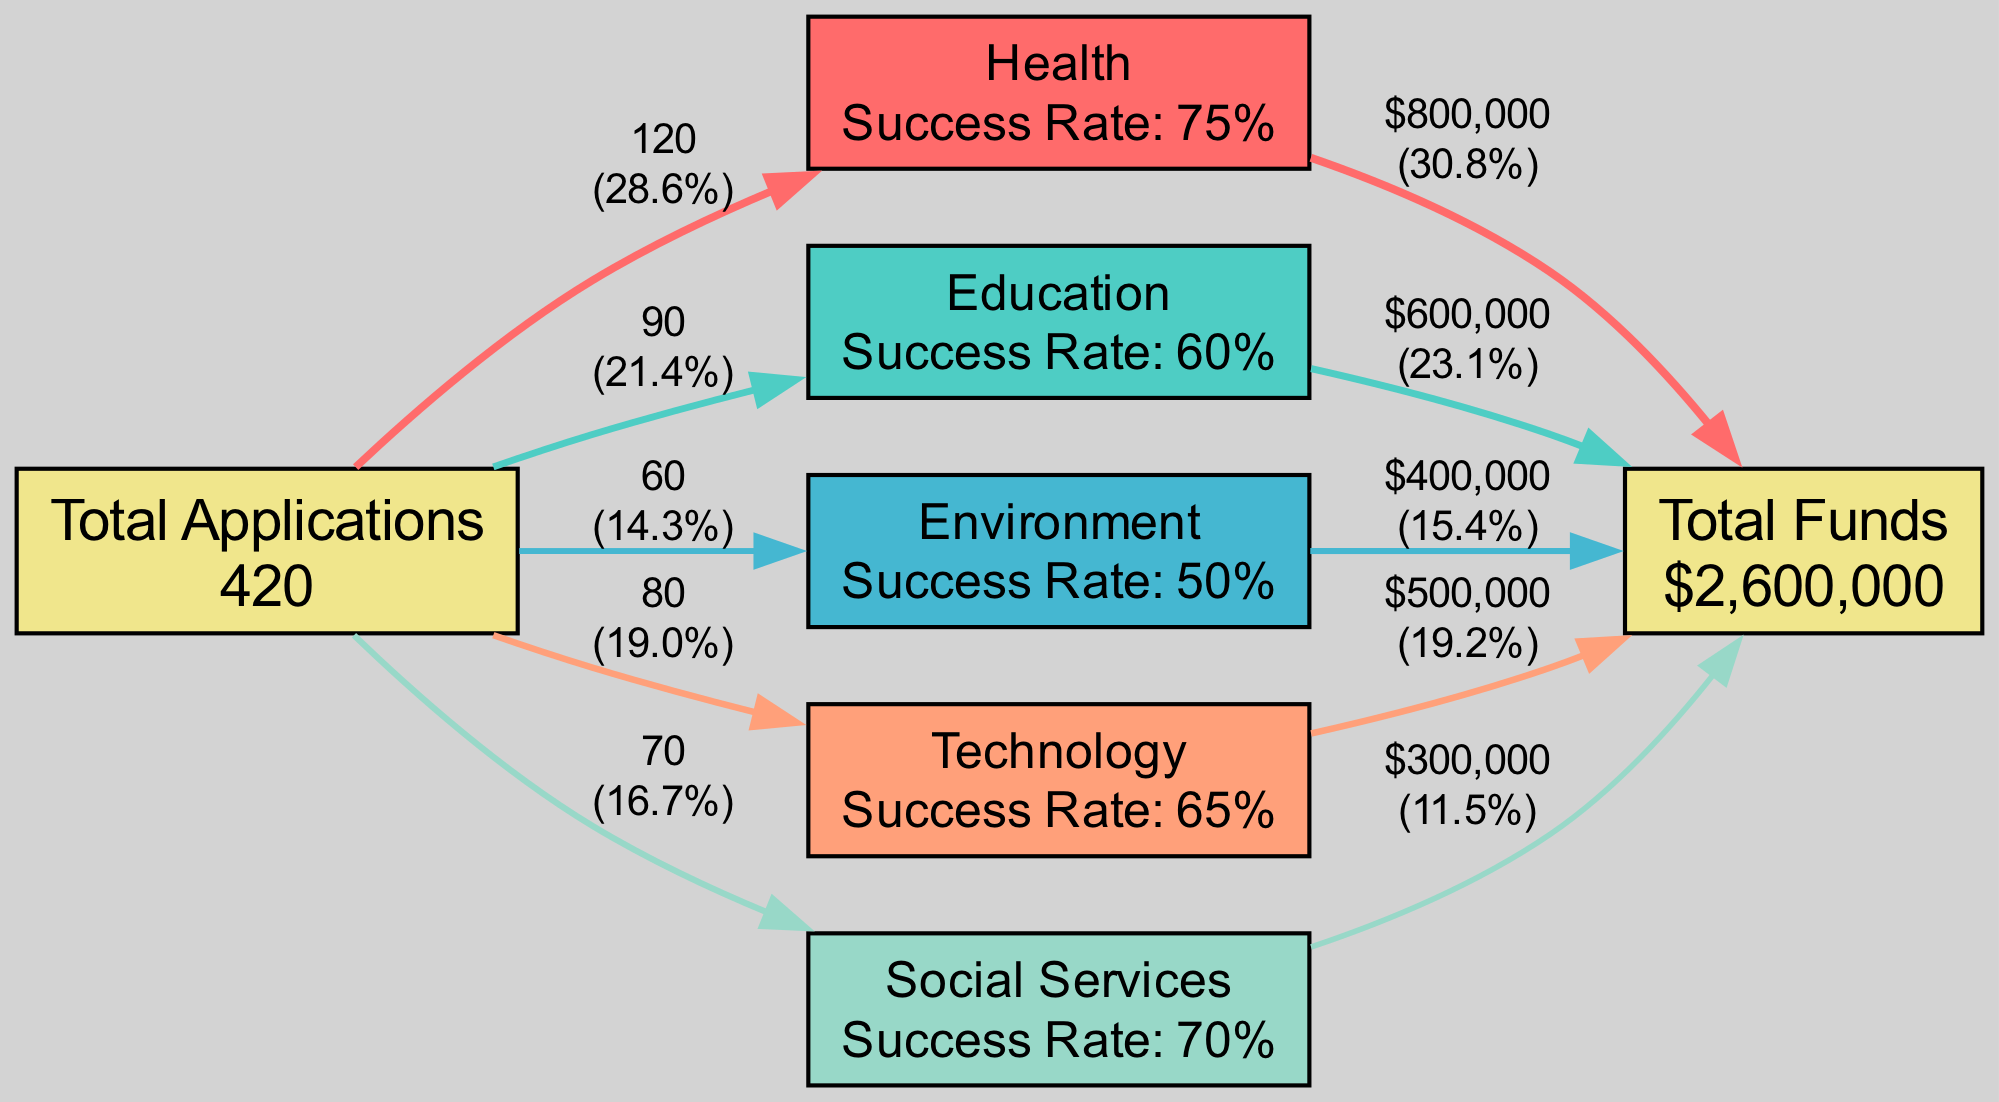What is the total amount of funds allocated? The diagram shows a node labeled "Total Funds" with a value of $2,600,000, which represents the total funds allocated across all sectors.
Answer: $2,600,000 Which sector received the highest funds allocated? By comparing the fund amounts labeled on each edge leading to the "Total Funds" node, the "Health" sector edges to the Total Funds node show the highest value of $800,000.
Answer: Health How many applications were received for the Technology sector? The diagram includes a label for the "Technology" sector node stating that 80 applications were received, which indicates the exact number.
Answer: 80 What is the success rate for the Education sector? Looking at the "Education" sector node, it displays "Success Rate: 60%," thus directly answering the question regarding its success rate.
Answer: 60% How many nodes are in the diagram? The diagram features a total of six nodes: one for Total Applications, one for Total Funds, and one for each of the five sectors (Health, Education, Environment, Technology, and Social Services). Therefore, the total node count is six.
Answer: 6 Which sector has the lowest success rate? Analyzing each sector's success rate shown in the corresponding nodes, the "Environment" sector shows the lowest success rate at 50%.
Answer: Environment What percentage of the total applications received comes from the Health sector? By calculating the flow from "Applications" to the "Health" sector and dividing the 120 applications received in Health by the total applications (which is 120 + 90 + 60 + 80 + 70 = 420), we find that the health sector received approximately 28.6% of total applications.
Answer: 28.6% How does the total number of applications received compare to the funds allocated? Looking at the summary in the diagram, the total applications received is 420, while the total funds allocated is $2,600,000, indicating that the funds allocated per application can be explored further based on these totals.
Answer: 420 applications to $2,600,000 funds Which sector has the highest percentage of total funds allocated? By dividing the funds allocated for each sector by the total funds and analyzing the edges to the "Total Funds" node, the "Health" sector receives 30.8% of total funds, representing the highest allocation percentage among the sectors.
Answer: Health 